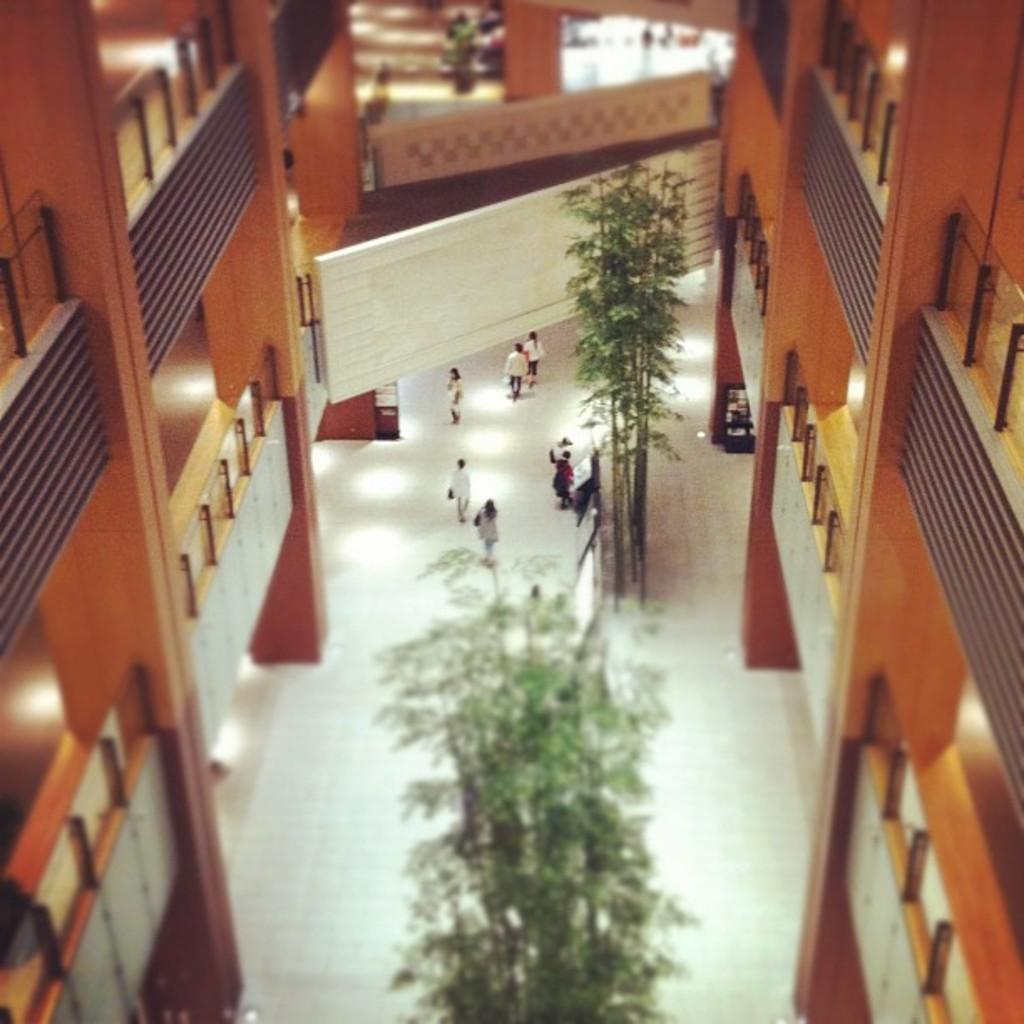What type of structure is visible in the image? There is a building in the image. What is happening at the bottom of the image? There are people walking on the floor at the bottom of the image. What type of vegetation can be seen in the image? There are trees in the image. How many planes are parked on the grass in the image? There are no planes visible in the image; it features a building, people walking, and trees. Can you spot a ladybug crawling on the leaves of the trees in the image? There is no ladybug present in the image. 